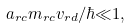<formula> <loc_0><loc_0><loc_500><loc_500>a _ { r c } m _ { r c } v _ { r d } / \hbar { \ll } 1 ,</formula> 